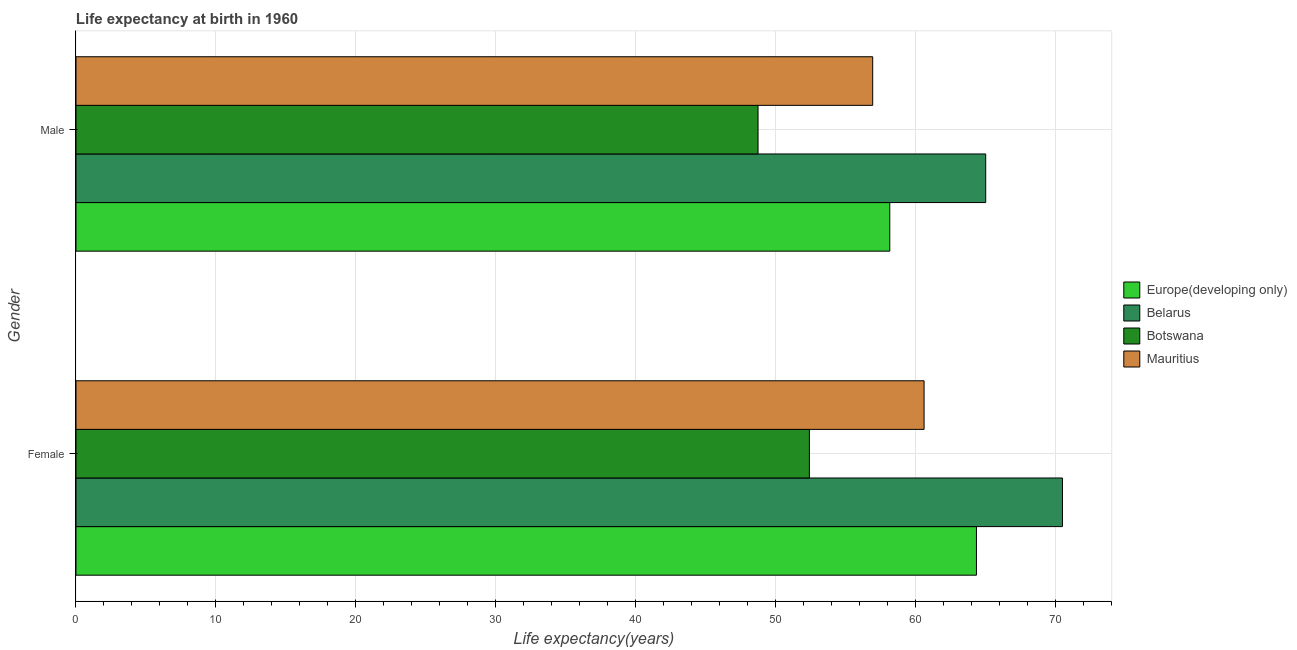How many different coloured bars are there?
Offer a very short reply. 4. Are the number of bars per tick equal to the number of legend labels?
Your answer should be very brief. Yes. Are the number of bars on each tick of the Y-axis equal?
Offer a very short reply. Yes. What is the label of the 2nd group of bars from the top?
Your answer should be compact. Female. What is the life expectancy(female) in Botswana?
Offer a very short reply. 52.43. Across all countries, what is the maximum life expectancy(male)?
Give a very brief answer. 65.03. Across all countries, what is the minimum life expectancy(male)?
Offer a terse response. 48.76. In which country was the life expectancy(male) maximum?
Provide a succinct answer. Belarus. In which country was the life expectancy(male) minimum?
Offer a very short reply. Botswana. What is the total life expectancy(male) in the graph?
Keep it short and to the point. 228.92. What is the difference between the life expectancy(male) in Europe(developing only) and that in Mauritius?
Keep it short and to the point. 1.22. What is the difference between the life expectancy(male) in Mauritius and the life expectancy(female) in Belarus?
Make the answer very short. -13.56. What is the average life expectancy(female) per country?
Provide a short and direct response. 61.99. What is the difference between the life expectancy(male) and life expectancy(female) in Europe(developing only)?
Your answer should be very brief. -6.2. In how many countries, is the life expectancy(female) greater than 36 years?
Make the answer very short. 4. What is the ratio of the life expectancy(male) in Mauritius to that in Botswana?
Offer a terse response. 1.17. In how many countries, is the life expectancy(male) greater than the average life expectancy(male) taken over all countries?
Make the answer very short. 2. What does the 4th bar from the top in Female represents?
Make the answer very short. Europe(developing only). What does the 4th bar from the bottom in Female represents?
Make the answer very short. Mauritius. How many bars are there?
Make the answer very short. 8. Are all the bars in the graph horizontal?
Your answer should be compact. Yes. How many countries are there in the graph?
Provide a succinct answer. 4. What is the difference between two consecutive major ticks on the X-axis?
Make the answer very short. 10. Does the graph contain any zero values?
Your answer should be very brief. No. Where does the legend appear in the graph?
Keep it short and to the point. Center right. What is the title of the graph?
Ensure brevity in your answer.  Life expectancy at birth in 1960. What is the label or title of the X-axis?
Provide a short and direct response. Life expectancy(years). What is the label or title of the Y-axis?
Provide a succinct answer. Gender. What is the Life expectancy(years) in Europe(developing only) in Female?
Your answer should be compact. 64.37. What is the Life expectancy(years) in Belarus in Female?
Give a very brief answer. 70.52. What is the Life expectancy(years) in Botswana in Female?
Provide a succinct answer. 52.43. What is the Life expectancy(years) in Mauritius in Female?
Your answer should be very brief. 60.63. What is the Life expectancy(years) of Europe(developing only) in Male?
Your answer should be very brief. 58.17. What is the Life expectancy(years) in Belarus in Male?
Offer a very short reply. 65.03. What is the Life expectancy(years) in Botswana in Male?
Provide a succinct answer. 48.76. What is the Life expectancy(years) of Mauritius in Male?
Keep it short and to the point. 56.95. Across all Gender, what is the maximum Life expectancy(years) of Europe(developing only)?
Your response must be concise. 64.37. Across all Gender, what is the maximum Life expectancy(years) of Belarus?
Your answer should be compact. 70.52. Across all Gender, what is the maximum Life expectancy(years) in Botswana?
Make the answer very short. 52.43. Across all Gender, what is the maximum Life expectancy(years) of Mauritius?
Your answer should be compact. 60.63. Across all Gender, what is the minimum Life expectancy(years) in Europe(developing only)?
Give a very brief answer. 58.17. Across all Gender, what is the minimum Life expectancy(years) of Belarus?
Provide a succinct answer. 65.03. Across all Gender, what is the minimum Life expectancy(years) in Botswana?
Provide a short and direct response. 48.76. Across all Gender, what is the minimum Life expectancy(years) in Mauritius?
Your response must be concise. 56.95. What is the total Life expectancy(years) of Europe(developing only) in the graph?
Give a very brief answer. 122.55. What is the total Life expectancy(years) in Belarus in the graph?
Keep it short and to the point. 135.55. What is the total Life expectancy(years) of Botswana in the graph?
Offer a terse response. 101.19. What is the total Life expectancy(years) of Mauritius in the graph?
Offer a terse response. 117.58. What is the difference between the Life expectancy(years) of Europe(developing only) in Female and that in Male?
Provide a short and direct response. 6.2. What is the difference between the Life expectancy(years) of Belarus in Female and that in Male?
Your answer should be very brief. 5.49. What is the difference between the Life expectancy(years) of Botswana in Female and that in Male?
Provide a short and direct response. 3.67. What is the difference between the Life expectancy(years) of Mauritius in Female and that in Male?
Offer a terse response. 3.67. What is the difference between the Life expectancy(years) of Europe(developing only) in Female and the Life expectancy(years) of Belarus in Male?
Your response must be concise. -0.66. What is the difference between the Life expectancy(years) of Europe(developing only) in Female and the Life expectancy(years) of Botswana in Male?
Keep it short and to the point. 15.61. What is the difference between the Life expectancy(years) of Europe(developing only) in Female and the Life expectancy(years) of Mauritius in Male?
Give a very brief answer. 7.42. What is the difference between the Life expectancy(years) of Belarus in Female and the Life expectancy(years) of Botswana in Male?
Your answer should be compact. 21.76. What is the difference between the Life expectancy(years) of Belarus in Female and the Life expectancy(years) of Mauritius in Male?
Keep it short and to the point. 13.56. What is the difference between the Life expectancy(years) in Botswana in Female and the Life expectancy(years) in Mauritius in Male?
Keep it short and to the point. -4.53. What is the average Life expectancy(years) in Europe(developing only) per Gender?
Your response must be concise. 61.27. What is the average Life expectancy(years) in Belarus per Gender?
Make the answer very short. 67.78. What is the average Life expectancy(years) in Botswana per Gender?
Give a very brief answer. 50.59. What is the average Life expectancy(years) of Mauritius per Gender?
Keep it short and to the point. 58.79. What is the difference between the Life expectancy(years) of Europe(developing only) and Life expectancy(years) of Belarus in Female?
Offer a very short reply. -6.15. What is the difference between the Life expectancy(years) in Europe(developing only) and Life expectancy(years) in Botswana in Female?
Ensure brevity in your answer.  11.94. What is the difference between the Life expectancy(years) in Europe(developing only) and Life expectancy(years) in Mauritius in Female?
Your answer should be compact. 3.75. What is the difference between the Life expectancy(years) of Belarus and Life expectancy(years) of Botswana in Female?
Provide a short and direct response. 18.09. What is the difference between the Life expectancy(years) of Belarus and Life expectancy(years) of Mauritius in Female?
Offer a very short reply. 9.89. What is the difference between the Life expectancy(years) of Botswana and Life expectancy(years) of Mauritius in Female?
Make the answer very short. -8.2. What is the difference between the Life expectancy(years) in Europe(developing only) and Life expectancy(years) in Belarus in Male?
Your response must be concise. -6.86. What is the difference between the Life expectancy(years) of Europe(developing only) and Life expectancy(years) of Botswana in Male?
Offer a terse response. 9.42. What is the difference between the Life expectancy(years) in Europe(developing only) and Life expectancy(years) in Mauritius in Male?
Offer a terse response. 1.22. What is the difference between the Life expectancy(years) of Belarus and Life expectancy(years) of Botswana in Male?
Your answer should be very brief. 16.27. What is the difference between the Life expectancy(years) in Belarus and Life expectancy(years) in Mauritius in Male?
Provide a short and direct response. 8.08. What is the difference between the Life expectancy(years) of Botswana and Life expectancy(years) of Mauritius in Male?
Offer a terse response. -8.2. What is the ratio of the Life expectancy(years) of Europe(developing only) in Female to that in Male?
Give a very brief answer. 1.11. What is the ratio of the Life expectancy(years) in Belarus in Female to that in Male?
Give a very brief answer. 1.08. What is the ratio of the Life expectancy(years) in Botswana in Female to that in Male?
Your answer should be very brief. 1.08. What is the ratio of the Life expectancy(years) of Mauritius in Female to that in Male?
Provide a succinct answer. 1.06. What is the difference between the highest and the second highest Life expectancy(years) in Europe(developing only)?
Make the answer very short. 6.2. What is the difference between the highest and the second highest Life expectancy(years) of Belarus?
Ensure brevity in your answer.  5.49. What is the difference between the highest and the second highest Life expectancy(years) in Botswana?
Offer a very short reply. 3.67. What is the difference between the highest and the second highest Life expectancy(years) of Mauritius?
Keep it short and to the point. 3.67. What is the difference between the highest and the lowest Life expectancy(years) of Europe(developing only)?
Offer a terse response. 6.2. What is the difference between the highest and the lowest Life expectancy(years) of Belarus?
Offer a very short reply. 5.49. What is the difference between the highest and the lowest Life expectancy(years) of Botswana?
Make the answer very short. 3.67. What is the difference between the highest and the lowest Life expectancy(years) of Mauritius?
Offer a very short reply. 3.67. 